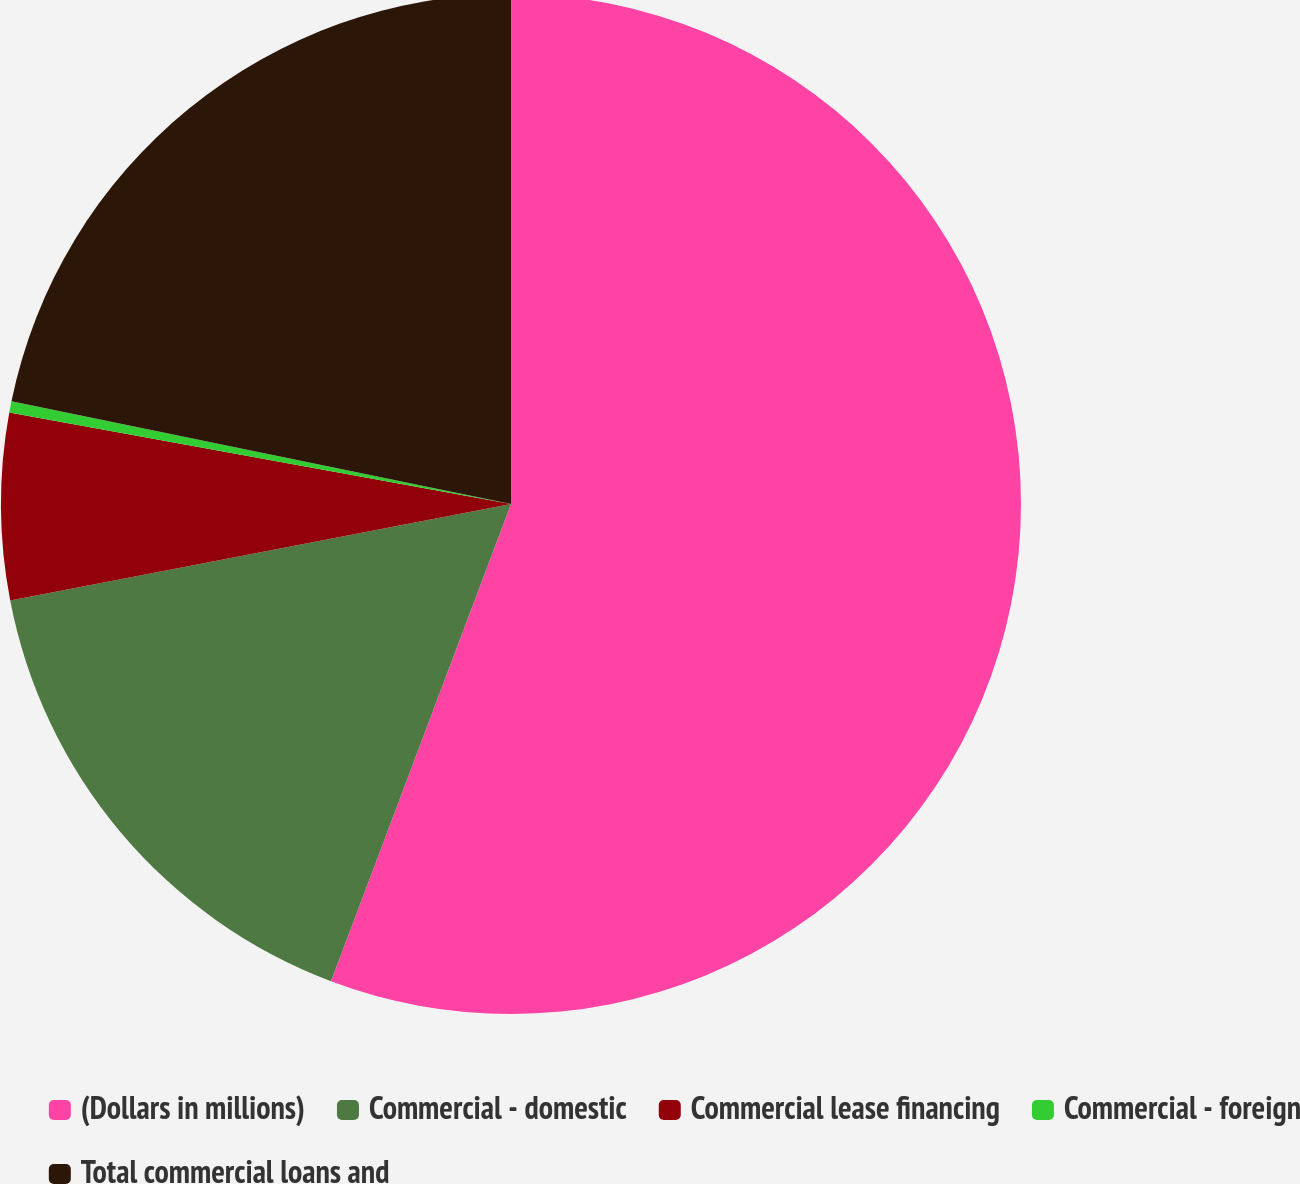Convert chart to OTSL. <chart><loc_0><loc_0><loc_500><loc_500><pie_chart><fcel>(Dollars in millions)<fcel>Commercial - domestic<fcel>Commercial lease financing<fcel>Commercial - foreign<fcel>Total commercial loans and<nl><fcel>55.74%<fcel>16.23%<fcel>5.9%<fcel>0.36%<fcel>21.77%<nl></chart> 